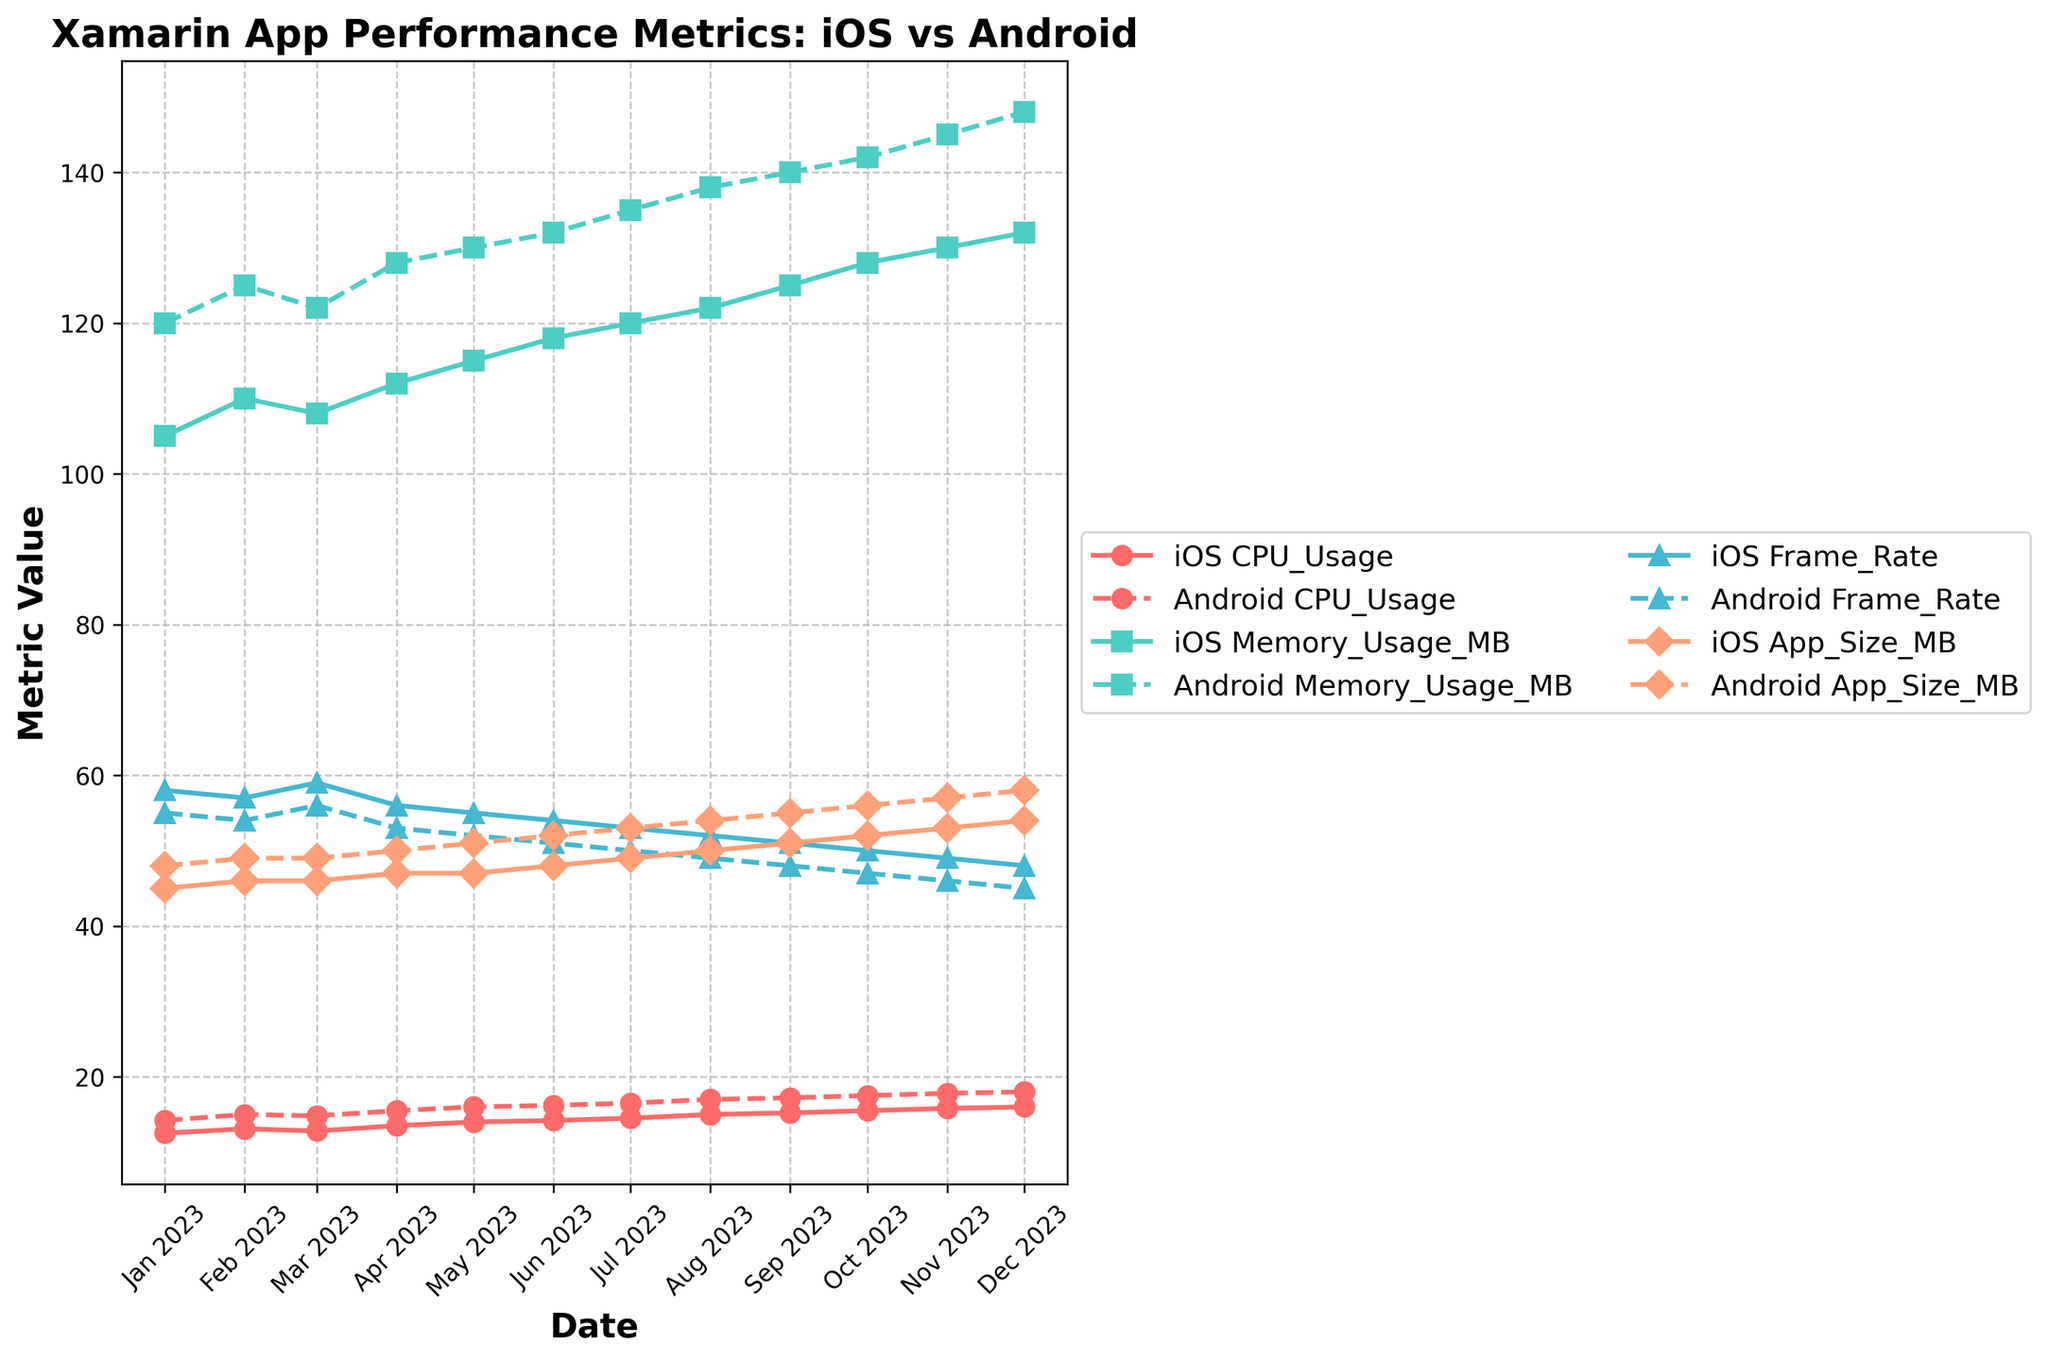What is the trend in iOS CPU usage over the year? To determine the trend, observe the iOS CPU Usage values from January to December. The values start at 12.5 in January and gradually increase each month, reaching 16.0 in December. This shows a rising trend over the year.
Answer: Rising trend Which platform has higher average memory usage? To find the average memory usage, sum up the memory usage values for each platform and divide by 12 (number of months). iOS: (105+110+108+112+115+118+120+122+125+128+130+132)/12 = 118.83. Android: (120+125+122+128+130+132+135+138+140+142+145+148)/12 = 132.08. Comparing the two, Android has higher average memory usage.
Answer: Android By how much did Android app size increase over the year? To determine the increase, subtract the app size in January from the app size in December for Android. December value: 58 MB, January value: 48 MB. So, 58 - 48 = 10 MB.
Answer: 10 MB Which platform has a higher frame rate in August? Look at the Frame Rate values for August. iOS Frame Rate is 52, and Android Frame Rate is 49. Therefore, iOS has a higher frame rate in August.
Answer: iOS How does the frame rate change for iOS from January to December? Observe the iOS Frame Rate values from January to December. The values start at 58 in January and decrease each month, dropping to 48 in December. This shows a declining trend over the year.
Answer: Declining trend What is the difference in memory usage between iOS and Android in June? Subtract the iOS Memory Usage value from the Android Memory Usage value for June. Android: 132 MB, iOS: 118 MB. So, 132 - 118 = 14 MB.
Answer: 14 MB What month has the smallest difference in CPU usage between iOS and Android? Calculate the differences for each month and identify the smallest. Differences: Jan: 1.7, Feb: 1.9, Mar: 2.0, Apr: 2.0, May: 2.0, Jun: 2.0, Jul: 2.0, Aug: 2.0, Sep: 2.0, Oct: 2.0, Nov: 2.0, Dec: 2.0. The smallest difference (1.7) is in January.
Answer: January Which metric shows the least variation for both platforms throughout the year? To determine variation, compare the range of values for each metric. For iOS, ranges are: CPU Usage: 3.5, Memory Usage: 27, Frame Rate: 10, App Size: 9. For Android, ranges are: CPU Usage: 3.8, Memory Usage: 28, Frame Rate: 10, App Size: 10. Both platforms show the least variation in Frame Rate.
Answer: Frame Rate During which month does iOS have the highest frame rate? Look for the highest iOS Frame Rate value. It occurs in March with a value of 59.
Answer: March When was the memory usage for Android exactly 135 MB? Locate the month where the Android Memory Usage value is 135 MB. It occurs in July.
Answer: July 